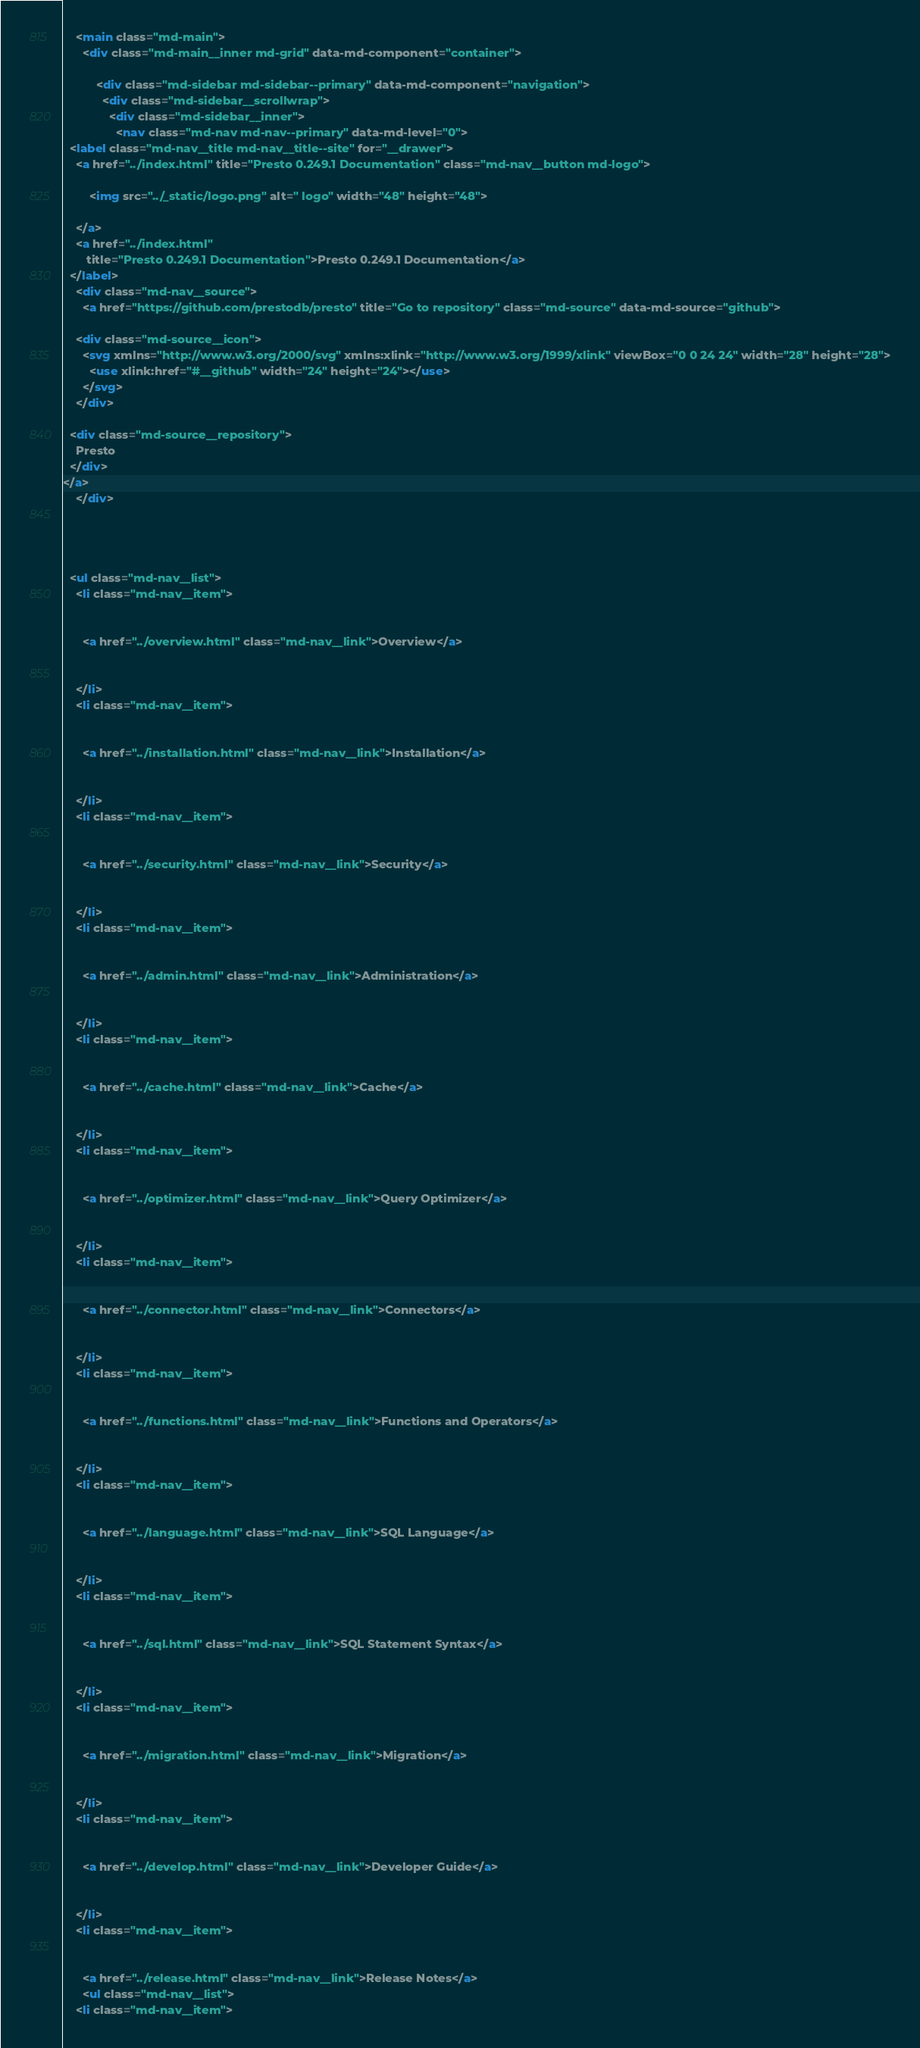Convert code to text. <code><loc_0><loc_0><loc_500><loc_500><_HTML_>    <main class="md-main">
      <div class="md-main__inner md-grid" data-md-component="container">
        
          <div class="md-sidebar md-sidebar--primary" data-md-component="navigation">
            <div class="md-sidebar__scrollwrap">
              <div class="md-sidebar__inner">
                <nav class="md-nav md-nav--primary" data-md-level="0">
  <label class="md-nav__title md-nav__title--site" for="__drawer">
    <a href="../index.html" title="Presto 0.249.1 Documentation" class="md-nav__button md-logo">
      
        <img src="../_static/logo.png" alt=" logo" width="48" height="48">
      
    </a>
    <a href="../index.html"
       title="Presto 0.249.1 Documentation">Presto 0.249.1 Documentation</a>
  </label>
    <div class="md-nav__source">
      <a href="https://github.com/prestodb/presto" title="Go to repository" class="md-source" data-md-source="github">

    <div class="md-source__icon">
      <svg xmlns="http://www.w3.org/2000/svg" xmlns:xlink="http://www.w3.org/1999/xlink" viewBox="0 0 24 24" width="28" height="28">
        <use xlink:href="#__github" width="24" height="24"></use>
      </svg>
    </div>
  
  <div class="md-source__repository">
    Presto
  </div>
</a>
    </div>
  
  

  
  <ul class="md-nav__list">
    <li class="md-nav__item">
    
    
      <a href="../overview.html" class="md-nav__link">Overview</a>
      
    
    </li>
    <li class="md-nav__item">
    
    
      <a href="../installation.html" class="md-nav__link">Installation</a>
      
    
    </li>
    <li class="md-nav__item">
    
    
      <a href="../security.html" class="md-nav__link">Security</a>
      
    
    </li>
    <li class="md-nav__item">
    
    
      <a href="../admin.html" class="md-nav__link">Administration</a>
      
    
    </li>
    <li class="md-nav__item">
    
    
      <a href="../cache.html" class="md-nav__link">Cache</a>
      
    
    </li>
    <li class="md-nav__item">
    
    
      <a href="../optimizer.html" class="md-nav__link">Query Optimizer</a>
      
    
    </li>
    <li class="md-nav__item">
    
    
      <a href="../connector.html" class="md-nav__link">Connectors</a>
      
    
    </li>
    <li class="md-nav__item">
    
    
      <a href="../functions.html" class="md-nav__link">Functions and Operators</a>
      
    
    </li>
    <li class="md-nav__item">
    
    
      <a href="../language.html" class="md-nav__link">SQL Language</a>
      
    
    </li>
    <li class="md-nav__item">
    
    
      <a href="../sql.html" class="md-nav__link">SQL Statement Syntax</a>
      
    
    </li>
    <li class="md-nav__item">
    
    
      <a href="../migration.html" class="md-nav__link">Migration</a>
      
    
    </li>
    <li class="md-nav__item">
    
    
      <a href="../develop.html" class="md-nav__link">Developer Guide</a>
      
    
    </li>
    <li class="md-nav__item">
    
    
      <a href="../release.html" class="md-nav__link">Release Notes</a>
      <ul class="md-nav__list"> 
    <li class="md-nav__item"></code> 